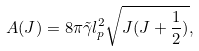<formula> <loc_0><loc_0><loc_500><loc_500>A ( J ) = 8 \pi \tilde { \gamma } l _ { p } ^ { 2 } \sqrt { J ( J + \frac { 1 } { 2 } ) } ,</formula> 